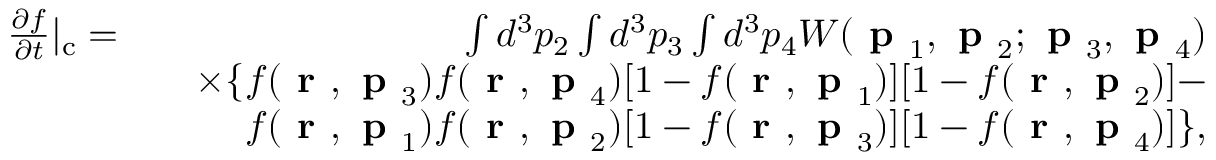Convert formula to latex. <formula><loc_0><loc_0><loc_500><loc_500>\begin{array} { r l r } { \frac { \partial f } { \partial t } | _ { c } = } & { \int d ^ { 3 } p _ { 2 } \int d ^ { 3 } p _ { 3 } \int d ^ { 3 } p _ { 4 } W ( p _ { 1 } , p _ { 2 } ; p _ { 3 } , p _ { 4 } ) } \\ & { \times \{ f ( r , p _ { 3 } ) f ( r , p _ { 4 } ) [ 1 - f ( r , p _ { 1 } ) ] [ 1 - f ( r , p _ { 2 } ) ] - } \\ & { f ( r , p _ { 1 } ) f ( r , p _ { 2 } ) [ 1 - f ( r , p _ { 3 } ) ] [ 1 - f ( r , p _ { 4 } ) ] \} , } \end{array}</formula> 